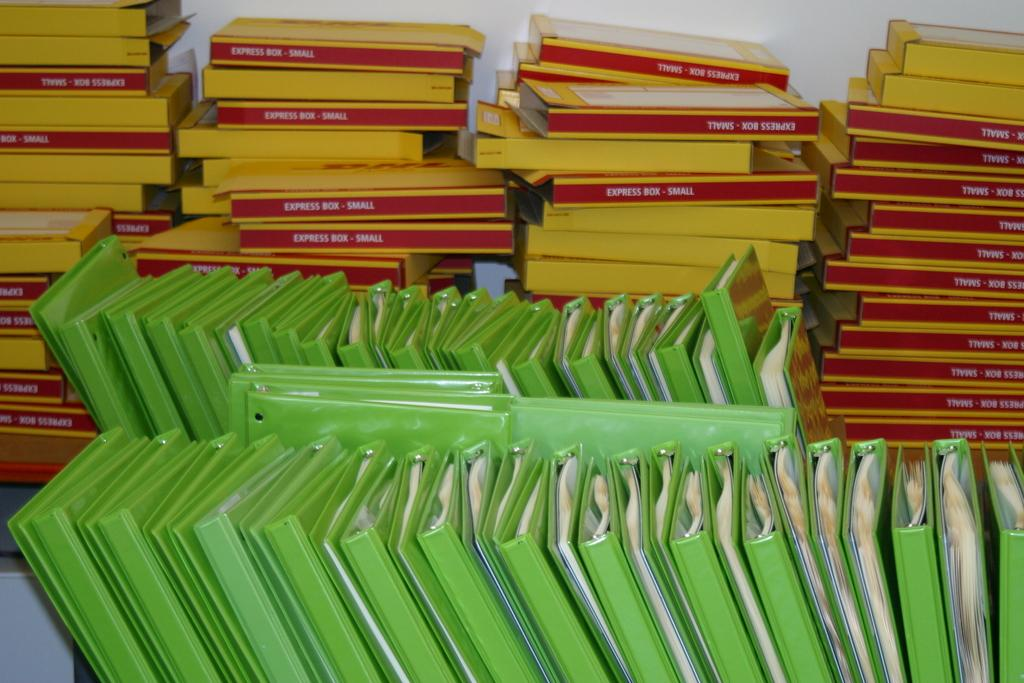What type of objects are located at the bottom side of the image? There are books at the bottom side of the image. What type of objects are located at the top side of the image? There are boxes at the top side of the image. Can you see a snail crawling on the books in the image? There is no snail present in the image. What type of fang can be seen on the boxes in the image? There are no fangs present on the boxes in the image. 